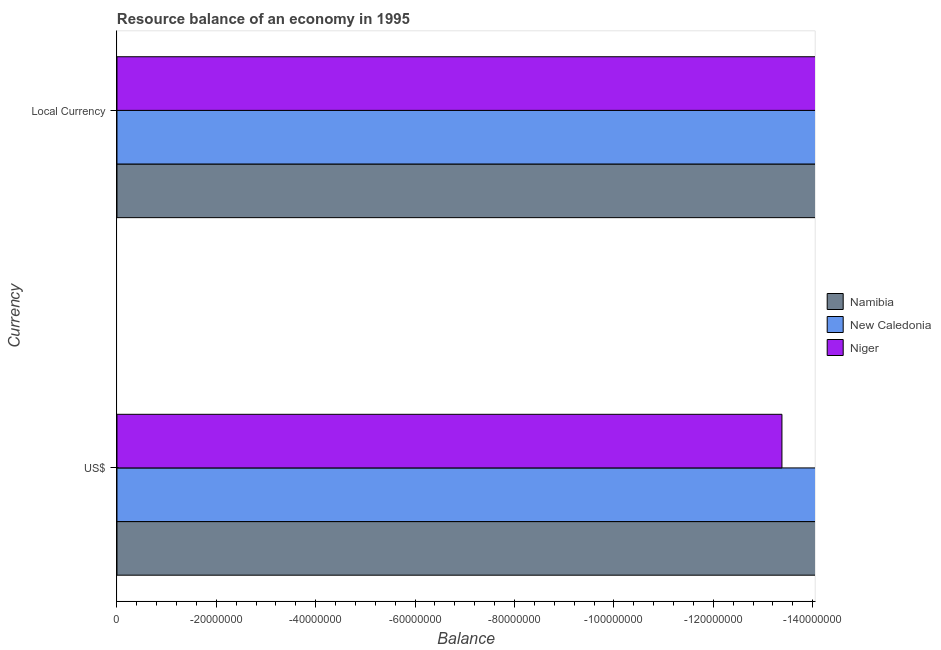Are the number of bars per tick equal to the number of legend labels?
Provide a short and direct response. No. Are the number of bars on each tick of the Y-axis equal?
Your answer should be compact. Yes. What is the label of the 1st group of bars from the top?
Provide a succinct answer. Local Currency. What is the total resource balance in constant us$ in the graph?
Give a very brief answer. 0. What is the difference between the resource balance in constant us$ in Niger and the resource balance in us$ in New Caledonia?
Provide a succinct answer. 0. What is the average resource balance in constant us$ per country?
Make the answer very short. 0. In how many countries, is the resource balance in constant us$ greater than the average resource balance in constant us$ taken over all countries?
Your response must be concise. 0. How many bars are there?
Keep it short and to the point. 0. Where does the legend appear in the graph?
Make the answer very short. Center right. How are the legend labels stacked?
Keep it short and to the point. Vertical. What is the title of the graph?
Provide a succinct answer. Resource balance of an economy in 1995. What is the label or title of the X-axis?
Offer a terse response. Balance. What is the label or title of the Y-axis?
Provide a succinct answer. Currency. What is the Balance of New Caledonia in US$?
Offer a terse response. 0. What is the Balance of Niger in US$?
Your response must be concise. 0. What is the total Balance in Namibia in the graph?
Keep it short and to the point. 0. What is the total Balance of Niger in the graph?
Your answer should be compact. 0. What is the average Balance of Namibia per Currency?
Your response must be concise. 0. What is the average Balance in New Caledonia per Currency?
Your answer should be compact. 0. 